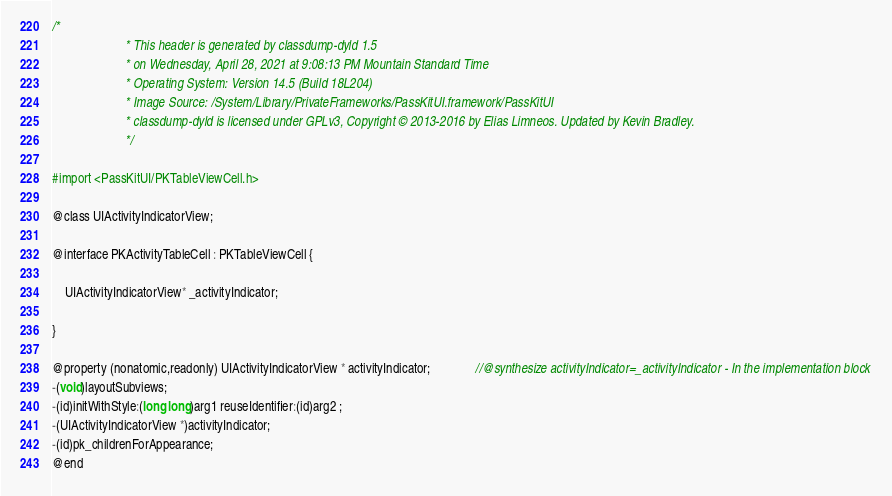Convert code to text. <code><loc_0><loc_0><loc_500><loc_500><_C_>/*
                       * This header is generated by classdump-dyld 1.5
                       * on Wednesday, April 28, 2021 at 9:08:13 PM Mountain Standard Time
                       * Operating System: Version 14.5 (Build 18L204)
                       * Image Source: /System/Library/PrivateFrameworks/PassKitUI.framework/PassKitUI
                       * classdump-dyld is licensed under GPLv3, Copyright © 2013-2016 by Elias Limneos. Updated by Kevin Bradley.
                       */

#import <PassKitUI/PKTableViewCell.h>

@class UIActivityIndicatorView;

@interface PKActivityTableCell : PKTableViewCell {

	UIActivityIndicatorView* _activityIndicator;

}

@property (nonatomic,readonly) UIActivityIndicatorView * activityIndicator;              //@synthesize activityIndicator=_activityIndicator - In the implementation block
-(void)layoutSubviews;
-(id)initWithStyle:(long long)arg1 reuseIdentifier:(id)arg2 ;
-(UIActivityIndicatorView *)activityIndicator;
-(id)pk_childrenForAppearance;
@end

</code> 